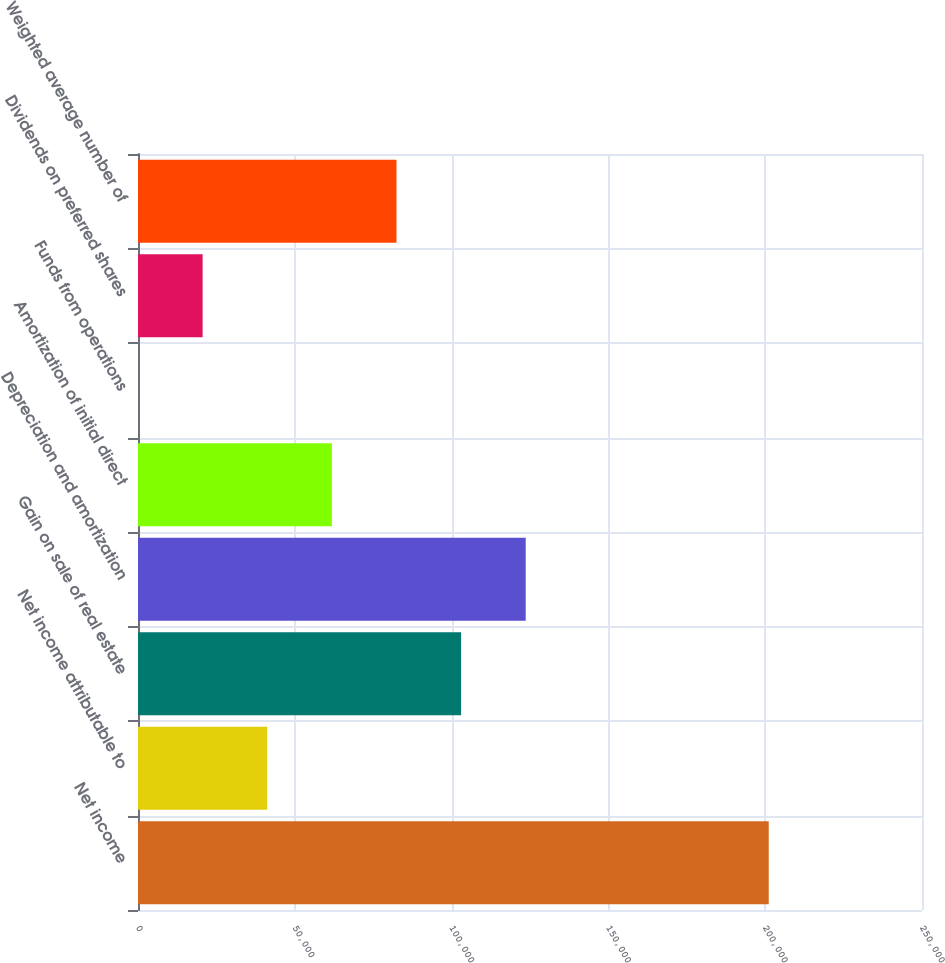Convert chart. <chart><loc_0><loc_0><loc_500><loc_500><bar_chart><fcel>Net income<fcel>Net income attributable to<fcel>Gain on sale of real estate<fcel>Depreciation and amortization<fcel>Amortization of initial direct<fcel>Funds from operations<fcel>Dividends on preferred shares<fcel>Weighted average number of<nl><fcel>201127<fcel>41212.5<fcel>103026<fcel>123630<fcel>61816.9<fcel>3.62<fcel>20608.1<fcel>82421.4<nl></chart> 